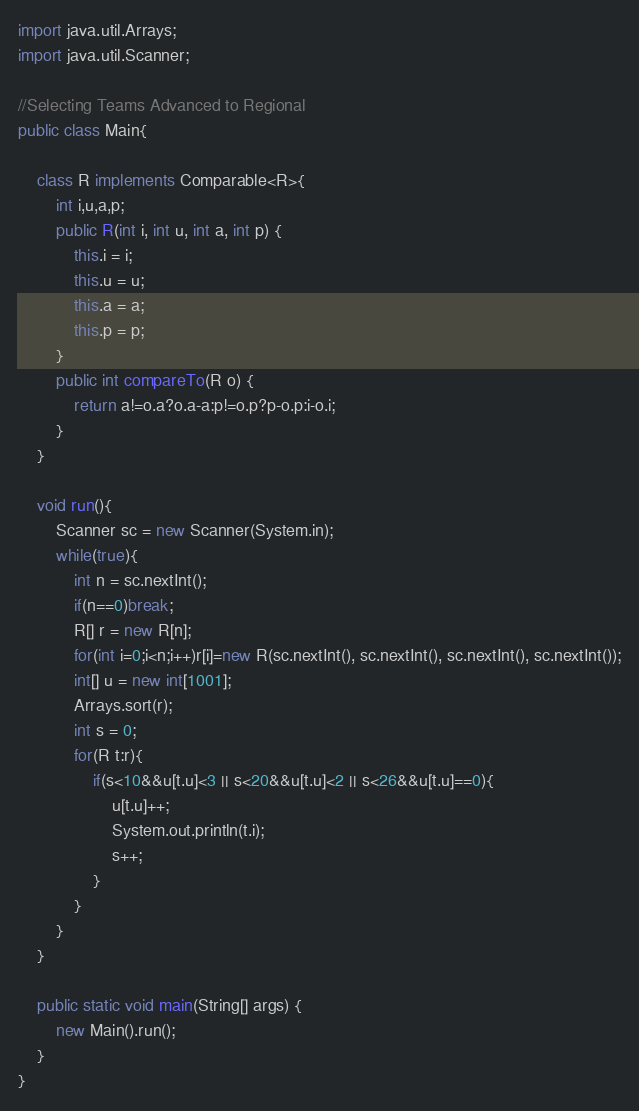<code> <loc_0><loc_0><loc_500><loc_500><_Java_>import java.util.Arrays;
import java.util.Scanner;

//Selecting Teams Advanced to Regional
public class Main{

	class R implements Comparable<R>{
		int i,u,a,p;
		public R(int i, int u, int a, int p) {
			this.i = i;
			this.u = u;
			this.a = a;
			this.p = p;
		}
		public int compareTo(R o) {
			return a!=o.a?o.a-a:p!=o.p?p-o.p:i-o.i;
		}
	}

	void run(){
		Scanner sc = new Scanner(System.in);
		while(true){
			int n = sc.nextInt();
			if(n==0)break;
			R[] r = new R[n];
			for(int i=0;i<n;i++)r[i]=new R(sc.nextInt(), sc.nextInt(), sc.nextInt(), sc.nextInt());
			int[] u = new int[1001];
			Arrays.sort(r);
			int s = 0;
			for(R t:r){
				if(s<10&&u[t.u]<3 || s<20&&u[t.u]<2 || s<26&&u[t.u]==0){
					u[t.u]++;
					System.out.println(t.i);
					s++;
				}
			}
		}
	}

	public static void main(String[] args) {
		new Main().run();
	}
}</code> 